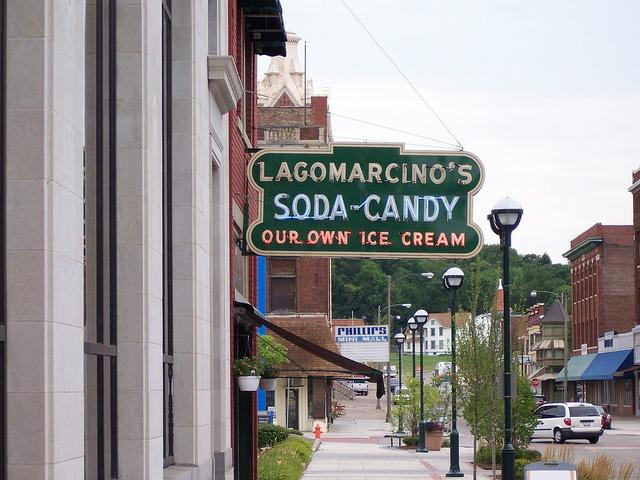What product is made at and for Lagomarcino's?

Choices:
A) wallets
B) wendy's shakes
C) ice cream
D) none ice cream 